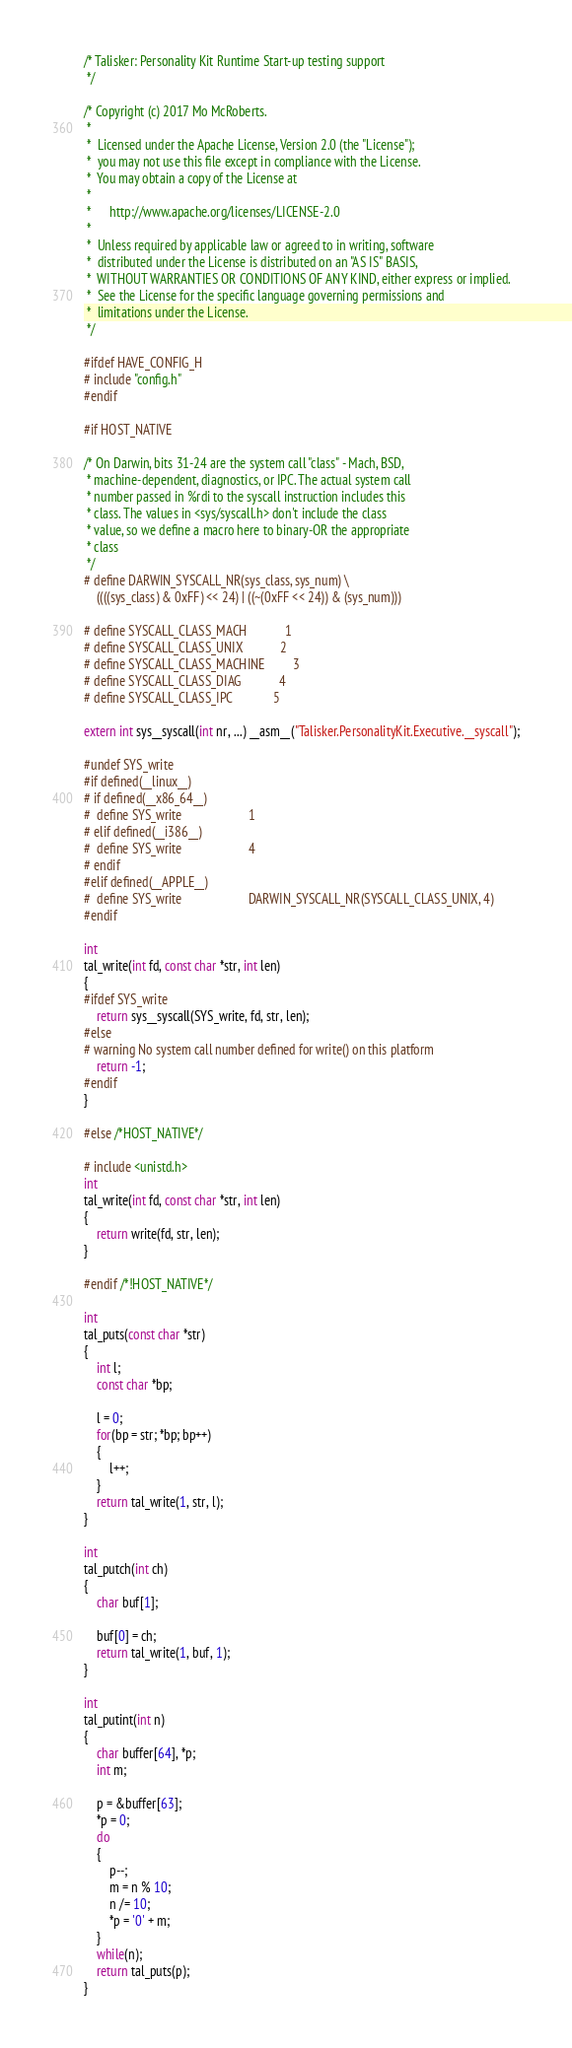<code> <loc_0><loc_0><loc_500><loc_500><_C_>/* Talisker: Personality Kit Runtime Start-up testing support
 */

/* Copyright (c) 2017 Mo McRoberts.
 *
 *  Licensed under the Apache License, Version 2.0 (the "License");
 *  you may not use this file except in compliance with the License.
 *  You may obtain a copy of the License at
 *
 *      http://www.apache.org/licenses/LICENSE-2.0
 *
 *  Unless required by applicable law or agreed to in writing, software
 *  distributed under the License is distributed on an "AS IS" BASIS,
 *  WITHOUT WARRANTIES OR CONDITIONS OF ANY KIND, either express or implied.
 *  See the License for the specific language governing permissions and
 *  limitations under the License.
 */

#ifdef HAVE_CONFIG_H
# include "config.h"
#endif

#if HOST_NATIVE

/* On Darwin, bits 31-24 are the system call "class" - Mach, BSD,
 * machine-dependent, diagnostics, or IPC. The actual system call
 * number passed in %rdi to the syscall instruction includes this
 * class. The values in <sys/syscall.h> don't include the class
 * value, so we define a macro here to binary-OR the appropriate
 * class
 */
# define DARWIN_SYSCALL_NR(sys_class, sys_num) \
	((((sys_class) & 0xFF) << 24) | ((~(0xFF << 24)) & (sys_num)))

# define SYSCALL_CLASS_MACH            1
# define SYSCALL_CLASS_UNIX            2
# define SYSCALL_CLASS_MACHINE         3
# define SYSCALL_CLASS_DIAG            4
# define SYSCALL_CLASS_IPC             5

extern int sys__syscall(int nr, ...) __asm__("Talisker.PersonalityKit.Executive.__syscall");

#undef SYS_write
#if defined(__linux__)
# if defined(__x86_64__)
#  define SYS_write                     1
# elif defined(__i386__)
#  define SYS_write                     4
# endif
#elif defined(__APPLE__)
#  define SYS_write                     DARWIN_SYSCALL_NR(SYSCALL_CLASS_UNIX, 4)
#endif

int
tal_write(int fd, const char *str, int len)
{
#ifdef SYS_write
	return sys__syscall(SYS_write, fd, str, len);
#else
# warning No system call number defined for write() on this platform
	return -1;
#endif
}

#else /*HOST_NATIVE*/

# include <unistd.h>
int
tal_write(int fd, const char *str, int len)
{
	return write(fd, str, len);
}

#endif /*!HOST_NATIVE*/

int
tal_puts(const char *str)
{
	int l;
	const char *bp;
	
	l = 0;
	for(bp = str; *bp; bp++)
	{
		l++;
	}
	return tal_write(1, str, l);
}

int
tal_putch(int ch)
{
	char buf[1];
	
	buf[0] = ch;
	return tal_write(1, buf, 1);
}

int
tal_putint(int n)
{
	char buffer[64], *p;
	int m;
	
	p = &buffer[63];
	*p = 0;
	do
	{
		p--;
		m = n % 10;
		n /= 10;
		*p = '0' + m;
	}
	while(n);
	return tal_puts(p);
}
</code> 